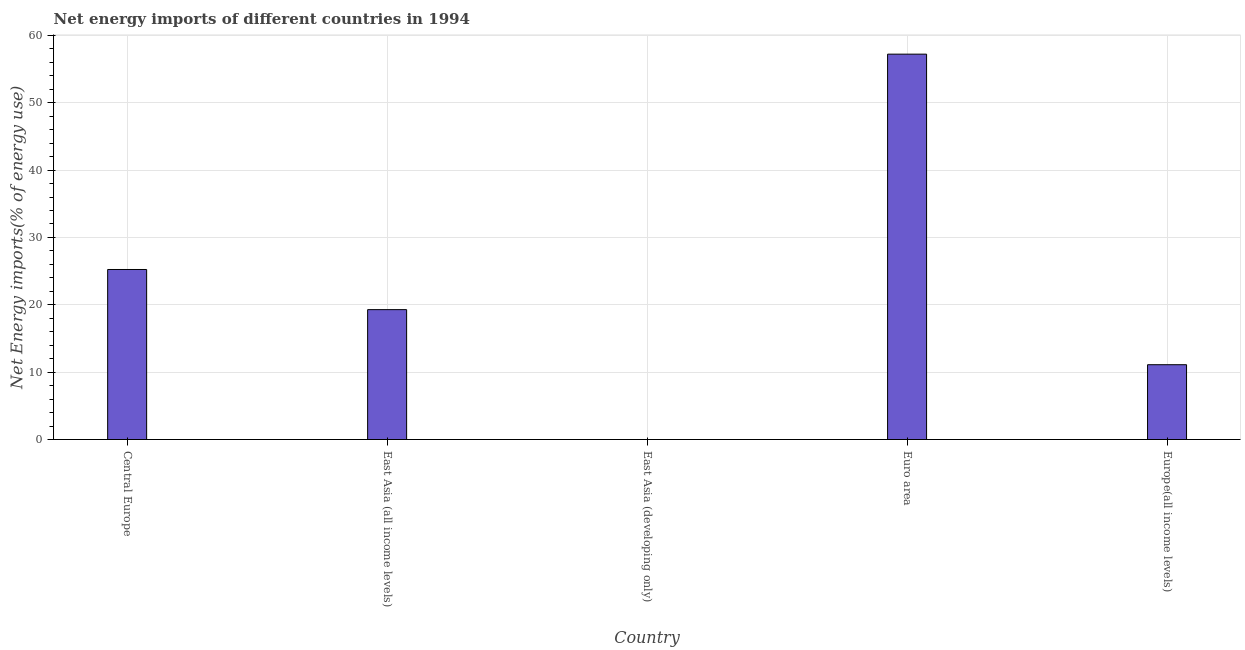Does the graph contain any zero values?
Keep it short and to the point. Yes. What is the title of the graph?
Provide a short and direct response. Net energy imports of different countries in 1994. What is the label or title of the Y-axis?
Make the answer very short. Net Energy imports(% of energy use). What is the energy imports in Central Europe?
Your answer should be very brief. 25.24. Across all countries, what is the maximum energy imports?
Ensure brevity in your answer.  57.22. In which country was the energy imports maximum?
Your response must be concise. Euro area. What is the sum of the energy imports?
Provide a succinct answer. 112.85. What is the difference between the energy imports in East Asia (all income levels) and Euro area?
Provide a succinct answer. -37.93. What is the average energy imports per country?
Ensure brevity in your answer.  22.57. What is the median energy imports?
Provide a succinct answer. 19.29. What is the ratio of the energy imports in Central Europe to that in Europe(all income levels)?
Provide a succinct answer. 2.27. What is the difference between the highest and the second highest energy imports?
Provide a succinct answer. 31.97. What is the difference between the highest and the lowest energy imports?
Make the answer very short. 57.22. In how many countries, is the energy imports greater than the average energy imports taken over all countries?
Your answer should be very brief. 2. How many bars are there?
Your answer should be very brief. 4. How many countries are there in the graph?
Make the answer very short. 5. What is the difference between two consecutive major ticks on the Y-axis?
Give a very brief answer. 10. What is the Net Energy imports(% of energy use) of Central Europe?
Your answer should be compact. 25.24. What is the Net Energy imports(% of energy use) of East Asia (all income levels)?
Offer a terse response. 19.29. What is the Net Energy imports(% of energy use) of East Asia (developing only)?
Your answer should be very brief. 0. What is the Net Energy imports(% of energy use) of Euro area?
Provide a short and direct response. 57.22. What is the Net Energy imports(% of energy use) in Europe(all income levels)?
Your response must be concise. 11.11. What is the difference between the Net Energy imports(% of energy use) in Central Europe and East Asia (all income levels)?
Keep it short and to the point. 5.96. What is the difference between the Net Energy imports(% of energy use) in Central Europe and Euro area?
Make the answer very short. -31.97. What is the difference between the Net Energy imports(% of energy use) in Central Europe and Europe(all income levels)?
Your answer should be very brief. 14.14. What is the difference between the Net Energy imports(% of energy use) in East Asia (all income levels) and Euro area?
Make the answer very short. -37.93. What is the difference between the Net Energy imports(% of energy use) in East Asia (all income levels) and Europe(all income levels)?
Make the answer very short. 8.18. What is the difference between the Net Energy imports(% of energy use) in Euro area and Europe(all income levels)?
Your response must be concise. 46.11. What is the ratio of the Net Energy imports(% of energy use) in Central Europe to that in East Asia (all income levels)?
Offer a terse response. 1.31. What is the ratio of the Net Energy imports(% of energy use) in Central Europe to that in Euro area?
Offer a terse response. 0.44. What is the ratio of the Net Energy imports(% of energy use) in Central Europe to that in Europe(all income levels)?
Provide a succinct answer. 2.27. What is the ratio of the Net Energy imports(% of energy use) in East Asia (all income levels) to that in Euro area?
Keep it short and to the point. 0.34. What is the ratio of the Net Energy imports(% of energy use) in East Asia (all income levels) to that in Europe(all income levels)?
Provide a short and direct response. 1.74. What is the ratio of the Net Energy imports(% of energy use) in Euro area to that in Europe(all income levels)?
Ensure brevity in your answer.  5.15. 